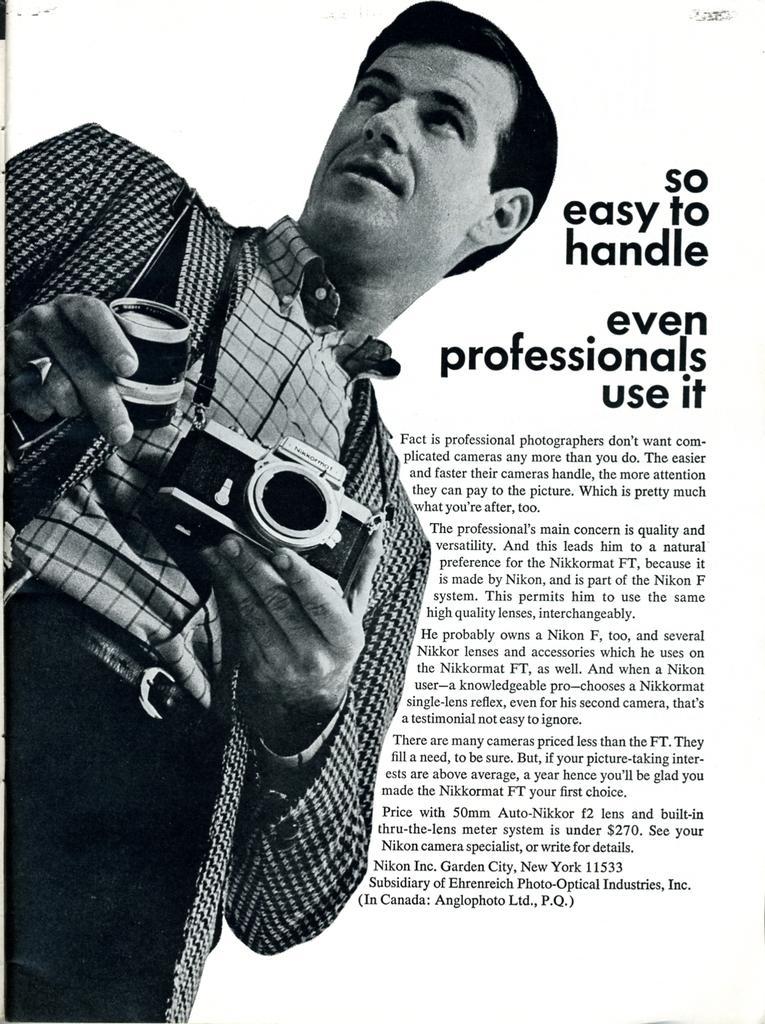Could you give a brief overview of what you see in this image? This is a poster and in this poster we can see a man holding an object, camera with his hands and some text. 